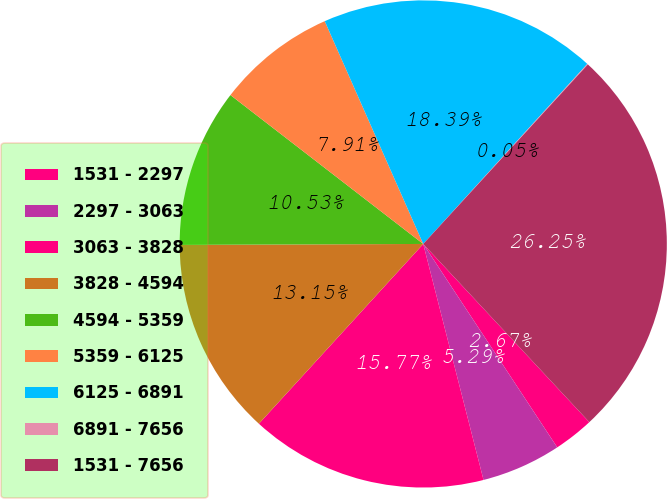Convert chart to OTSL. <chart><loc_0><loc_0><loc_500><loc_500><pie_chart><fcel>1531 - 2297<fcel>2297 - 3063<fcel>3063 - 3828<fcel>3828 - 4594<fcel>4594 - 5359<fcel>5359 - 6125<fcel>6125 - 6891<fcel>6891 - 7656<fcel>1531 - 7656<nl><fcel>2.67%<fcel>5.29%<fcel>15.77%<fcel>13.15%<fcel>10.53%<fcel>7.91%<fcel>18.39%<fcel>0.05%<fcel>26.25%<nl></chart> 